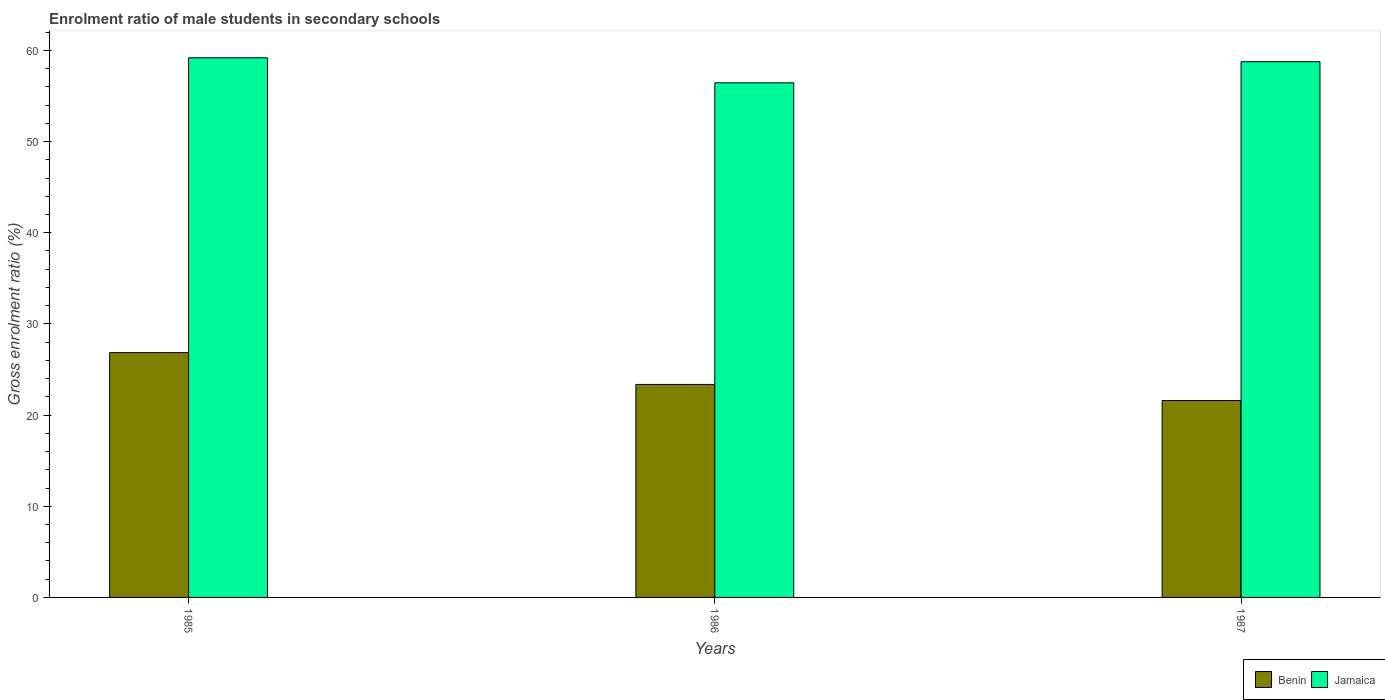How many different coloured bars are there?
Offer a terse response. 2. Are the number of bars per tick equal to the number of legend labels?
Your answer should be very brief. Yes. What is the label of the 1st group of bars from the left?
Offer a terse response. 1985. What is the enrolment ratio of male students in secondary schools in Benin in 1986?
Offer a terse response. 23.36. Across all years, what is the maximum enrolment ratio of male students in secondary schools in Jamaica?
Your answer should be compact. 59.18. Across all years, what is the minimum enrolment ratio of male students in secondary schools in Jamaica?
Your answer should be very brief. 56.44. In which year was the enrolment ratio of male students in secondary schools in Benin maximum?
Offer a terse response. 1985. What is the total enrolment ratio of male students in secondary schools in Jamaica in the graph?
Provide a succinct answer. 174.37. What is the difference between the enrolment ratio of male students in secondary schools in Benin in 1986 and that in 1987?
Your answer should be compact. 1.76. What is the difference between the enrolment ratio of male students in secondary schools in Benin in 1986 and the enrolment ratio of male students in secondary schools in Jamaica in 1985?
Make the answer very short. -35.82. What is the average enrolment ratio of male students in secondary schools in Benin per year?
Offer a very short reply. 23.94. In the year 1985, what is the difference between the enrolment ratio of male students in secondary schools in Jamaica and enrolment ratio of male students in secondary schools in Benin?
Give a very brief answer. 32.33. In how many years, is the enrolment ratio of male students in secondary schools in Jamaica greater than 18 %?
Provide a succinct answer. 3. What is the ratio of the enrolment ratio of male students in secondary schools in Benin in 1986 to that in 1987?
Provide a short and direct response. 1.08. Is the difference between the enrolment ratio of male students in secondary schools in Jamaica in 1985 and 1986 greater than the difference between the enrolment ratio of male students in secondary schools in Benin in 1985 and 1986?
Provide a short and direct response. No. What is the difference between the highest and the second highest enrolment ratio of male students in secondary schools in Benin?
Your response must be concise. 3.49. What is the difference between the highest and the lowest enrolment ratio of male students in secondary schools in Jamaica?
Provide a short and direct response. 2.74. In how many years, is the enrolment ratio of male students in secondary schools in Jamaica greater than the average enrolment ratio of male students in secondary schools in Jamaica taken over all years?
Your answer should be very brief. 2. Is the sum of the enrolment ratio of male students in secondary schools in Jamaica in 1986 and 1987 greater than the maximum enrolment ratio of male students in secondary schools in Benin across all years?
Make the answer very short. Yes. What does the 2nd bar from the left in 1985 represents?
Provide a short and direct response. Jamaica. What does the 2nd bar from the right in 1987 represents?
Ensure brevity in your answer.  Benin. How many bars are there?
Keep it short and to the point. 6. How many years are there in the graph?
Provide a succinct answer. 3. What is the difference between two consecutive major ticks on the Y-axis?
Your answer should be very brief. 10. Where does the legend appear in the graph?
Make the answer very short. Bottom right. How are the legend labels stacked?
Keep it short and to the point. Horizontal. What is the title of the graph?
Give a very brief answer. Enrolment ratio of male students in secondary schools. Does "Liechtenstein" appear as one of the legend labels in the graph?
Your answer should be very brief. No. What is the label or title of the Y-axis?
Your answer should be compact. Gross enrolment ratio (%). What is the Gross enrolment ratio (%) in Benin in 1985?
Your response must be concise. 26.85. What is the Gross enrolment ratio (%) in Jamaica in 1985?
Your response must be concise. 59.18. What is the Gross enrolment ratio (%) in Benin in 1986?
Your answer should be very brief. 23.36. What is the Gross enrolment ratio (%) of Jamaica in 1986?
Provide a succinct answer. 56.44. What is the Gross enrolment ratio (%) in Benin in 1987?
Offer a terse response. 21.6. What is the Gross enrolment ratio (%) in Jamaica in 1987?
Provide a short and direct response. 58.75. Across all years, what is the maximum Gross enrolment ratio (%) in Benin?
Give a very brief answer. 26.85. Across all years, what is the maximum Gross enrolment ratio (%) of Jamaica?
Your answer should be compact. 59.18. Across all years, what is the minimum Gross enrolment ratio (%) of Benin?
Give a very brief answer. 21.6. Across all years, what is the minimum Gross enrolment ratio (%) in Jamaica?
Offer a terse response. 56.44. What is the total Gross enrolment ratio (%) of Benin in the graph?
Offer a very short reply. 71.81. What is the total Gross enrolment ratio (%) of Jamaica in the graph?
Your answer should be compact. 174.37. What is the difference between the Gross enrolment ratio (%) in Benin in 1985 and that in 1986?
Provide a short and direct response. 3.49. What is the difference between the Gross enrolment ratio (%) in Jamaica in 1985 and that in 1986?
Keep it short and to the point. 2.74. What is the difference between the Gross enrolment ratio (%) of Benin in 1985 and that in 1987?
Offer a terse response. 5.25. What is the difference between the Gross enrolment ratio (%) in Jamaica in 1985 and that in 1987?
Give a very brief answer. 0.43. What is the difference between the Gross enrolment ratio (%) in Benin in 1986 and that in 1987?
Make the answer very short. 1.76. What is the difference between the Gross enrolment ratio (%) of Jamaica in 1986 and that in 1987?
Your answer should be compact. -2.31. What is the difference between the Gross enrolment ratio (%) in Benin in 1985 and the Gross enrolment ratio (%) in Jamaica in 1986?
Your answer should be very brief. -29.59. What is the difference between the Gross enrolment ratio (%) in Benin in 1985 and the Gross enrolment ratio (%) in Jamaica in 1987?
Ensure brevity in your answer.  -31.9. What is the difference between the Gross enrolment ratio (%) in Benin in 1986 and the Gross enrolment ratio (%) in Jamaica in 1987?
Give a very brief answer. -35.39. What is the average Gross enrolment ratio (%) in Benin per year?
Your answer should be very brief. 23.94. What is the average Gross enrolment ratio (%) in Jamaica per year?
Offer a very short reply. 58.12. In the year 1985, what is the difference between the Gross enrolment ratio (%) of Benin and Gross enrolment ratio (%) of Jamaica?
Provide a short and direct response. -32.33. In the year 1986, what is the difference between the Gross enrolment ratio (%) of Benin and Gross enrolment ratio (%) of Jamaica?
Keep it short and to the point. -33.08. In the year 1987, what is the difference between the Gross enrolment ratio (%) in Benin and Gross enrolment ratio (%) in Jamaica?
Your answer should be compact. -37.15. What is the ratio of the Gross enrolment ratio (%) of Benin in 1985 to that in 1986?
Your answer should be very brief. 1.15. What is the ratio of the Gross enrolment ratio (%) in Jamaica in 1985 to that in 1986?
Provide a short and direct response. 1.05. What is the ratio of the Gross enrolment ratio (%) in Benin in 1985 to that in 1987?
Your answer should be compact. 1.24. What is the ratio of the Gross enrolment ratio (%) of Jamaica in 1985 to that in 1987?
Your response must be concise. 1.01. What is the ratio of the Gross enrolment ratio (%) in Benin in 1986 to that in 1987?
Offer a very short reply. 1.08. What is the ratio of the Gross enrolment ratio (%) of Jamaica in 1986 to that in 1987?
Keep it short and to the point. 0.96. What is the difference between the highest and the second highest Gross enrolment ratio (%) of Benin?
Your answer should be compact. 3.49. What is the difference between the highest and the second highest Gross enrolment ratio (%) of Jamaica?
Provide a short and direct response. 0.43. What is the difference between the highest and the lowest Gross enrolment ratio (%) of Benin?
Ensure brevity in your answer.  5.25. What is the difference between the highest and the lowest Gross enrolment ratio (%) of Jamaica?
Make the answer very short. 2.74. 